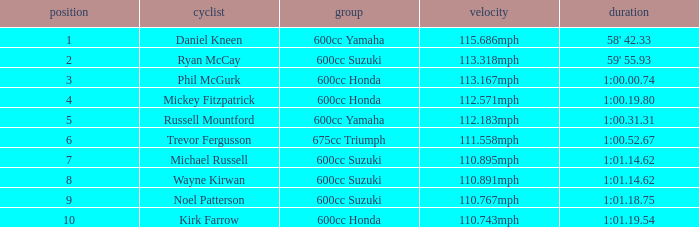How many ranks have michael russell as the rider? 7.0. Would you be able to parse every entry in this table? {'header': ['position', 'cyclist', 'group', 'velocity', 'duration'], 'rows': [['1', 'Daniel Kneen', '600cc Yamaha', '115.686mph', "58' 42.33"], ['2', 'Ryan McCay', '600cc Suzuki', '113.318mph', "59' 55.93"], ['3', 'Phil McGurk', '600cc Honda', '113.167mph', '1:00.00.74'], ['4', 'Mickey Fitzpatrick', '600cc Honda', '112.571mph', '1:00.19.80'], ['5', 'Russell Mountford', '600cc Yamaha', '112.183mph', '1:00.31.31'], ['6', 'Trevor Fergusson', '675cc Triumph', '111.558mph', '1:00.52.67'], ['7', 'Michael Russell', '600cc Suzuki', '110.895mph', '1:01.14.62'], ['8', 'Wayne Kirwan', '600cc Suzuki', '110.891mph', '1:01.14.62'], ['9', 'Noel Patterson', '600cc Suzuki', '110.767mph', '1:01.18.75'], ['10', 'Kirk Farrow', '600cc Honda', '110.743mph', '1:01.19.54']]} 